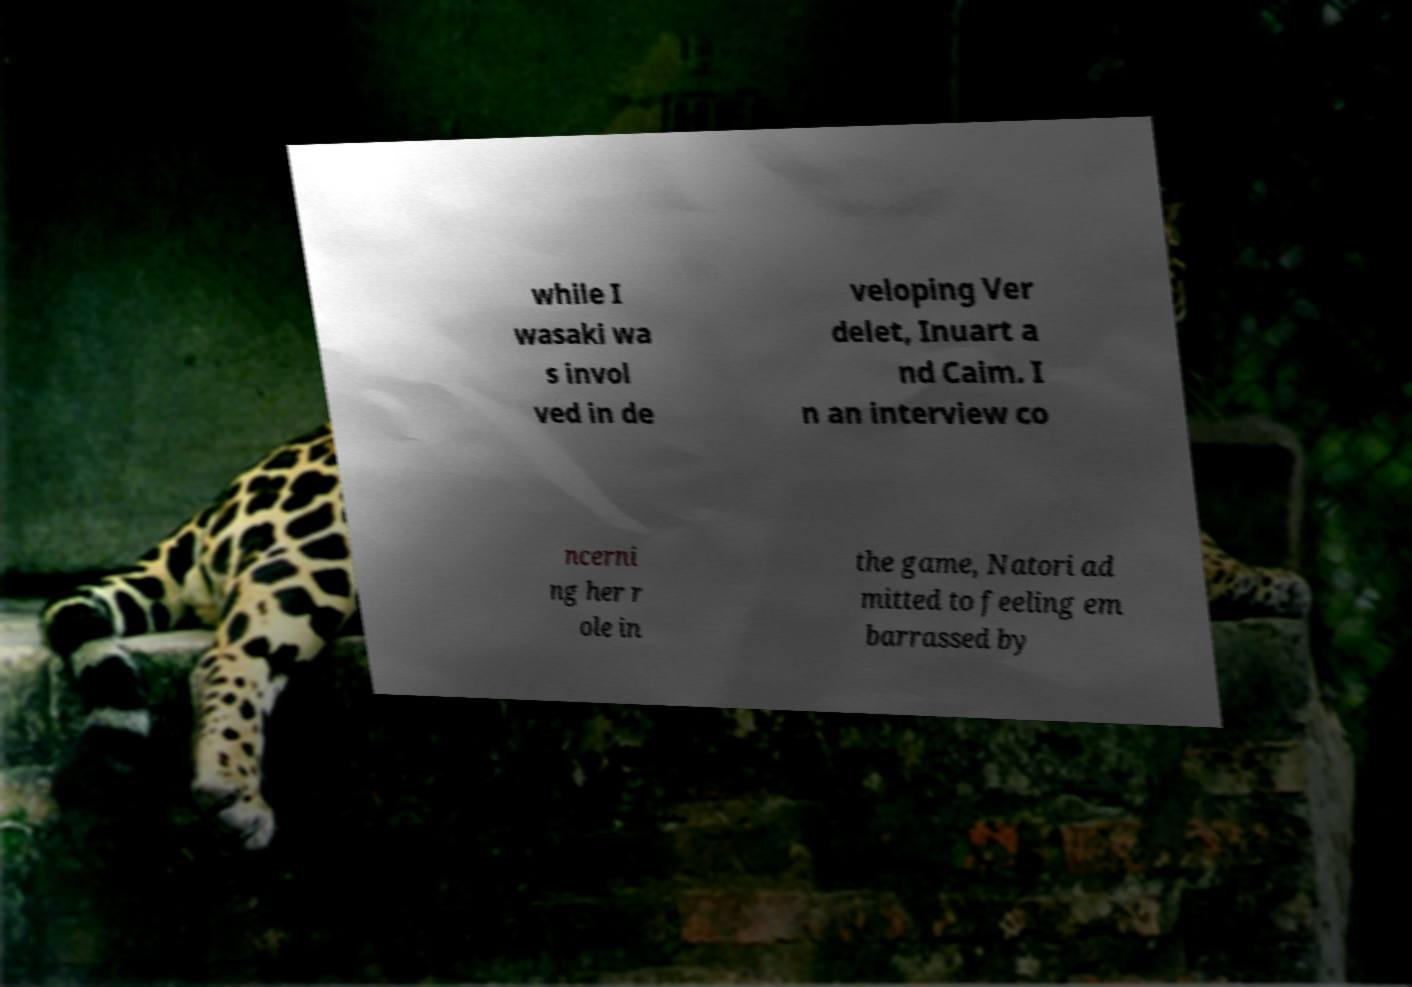Please identify and transcribe the text found in this image. while I wasaki wa s invol ved in de veloping Ver delet, Inuart a nd Caim. I n an interview co ncerni ng her r ole in the game, Natori ad mitted to feeling em barrassed by 